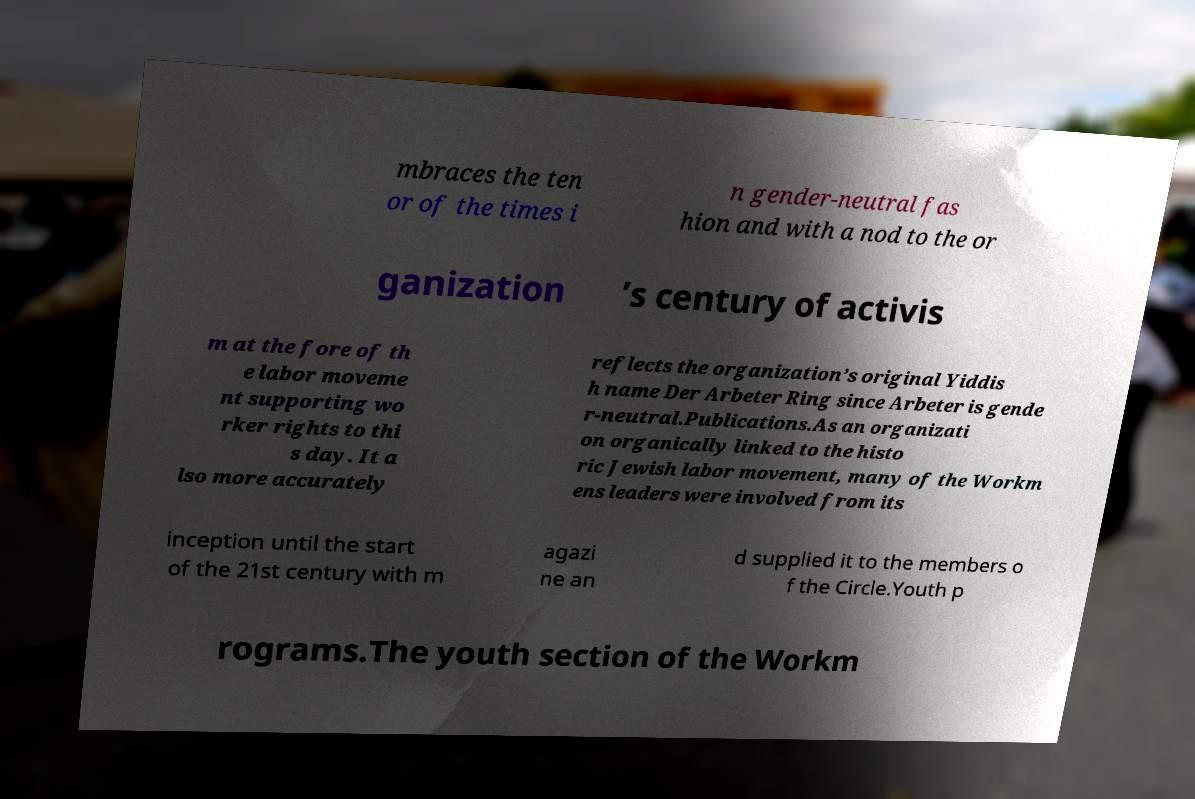Please read and relay the text visible in this image. What does it say? mbraces the ten or of the times i n gender-neutral fas hion and with a nod to the or ganization ’s century of activis m at the fore of th e labor moveme nt supporting wo rker rights to thi s day. It a lso more accurately reflects the organization’s original Yiddis h name Der Arbeter Ring since Arbeter is gende r-neutral.Publications.As an organizati on organically linked to the histo ric Jewish labor movement, many of the Workm ens leaders were involved from its inception until the start of the 21st century with m agazi ne an d supplied it to the members o f the Circle.Youth p rograms.The youth section of the Workm 